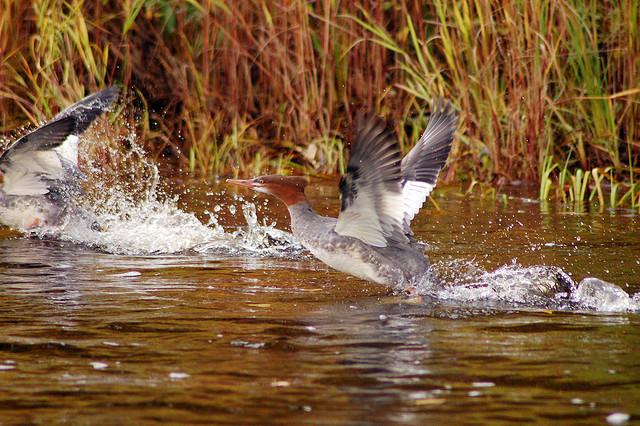How many bird heads are in the scene?
Concise answer only. 1. Are the birds following each other?
Write a very short answer. Yes. Is the bird gray?
Concise answer only. Yes. 